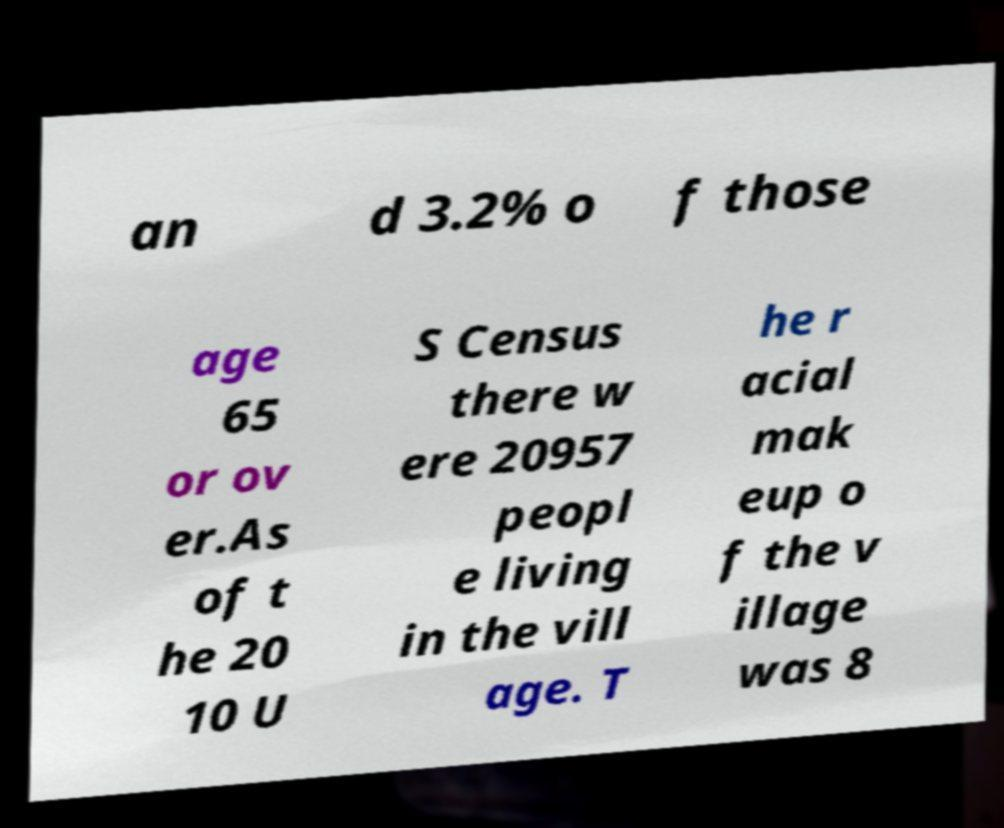Please read and relay the text visible in this image. What does it say? an d 3.2% o f those age 65 or ov er.As of t he 20 10 U S Census there w ere 20957 peopl e living in the vill age. T he r acial mak eup o f the v illage was 8 